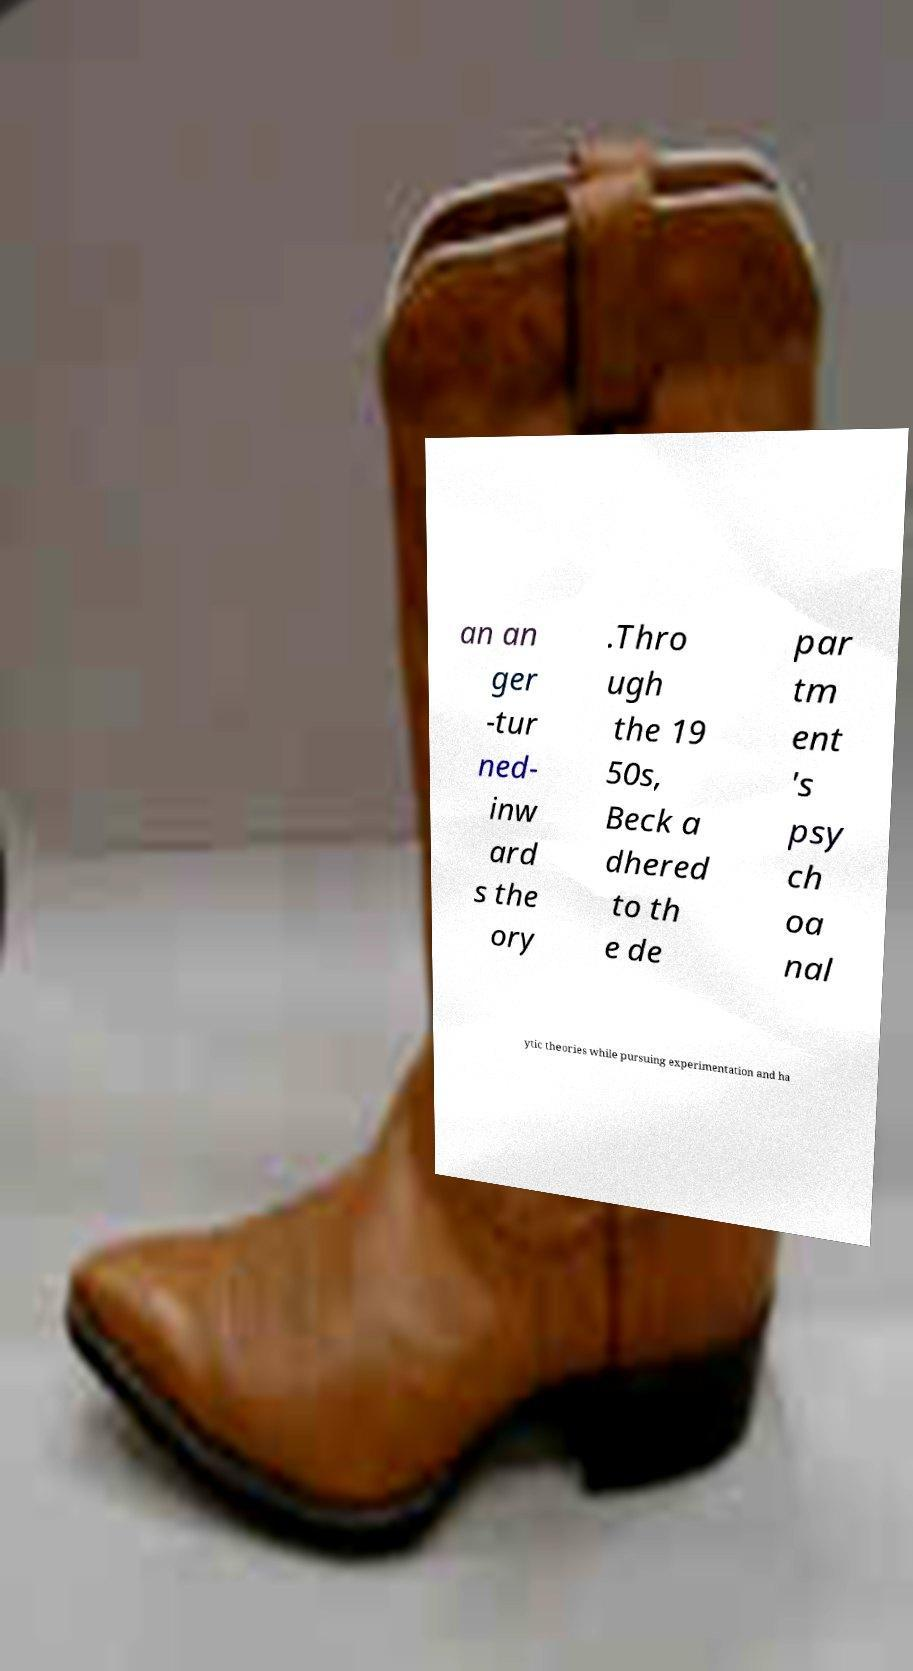Please read and relay the text visible in this image. What does it say? an an ger -tur ned- inw ard s the ory .Thro ugh the 19 50s, Beck a dhered to th e de par tm ent 's psy ch oa nal ytic theories while pursuing experimentation and ha 